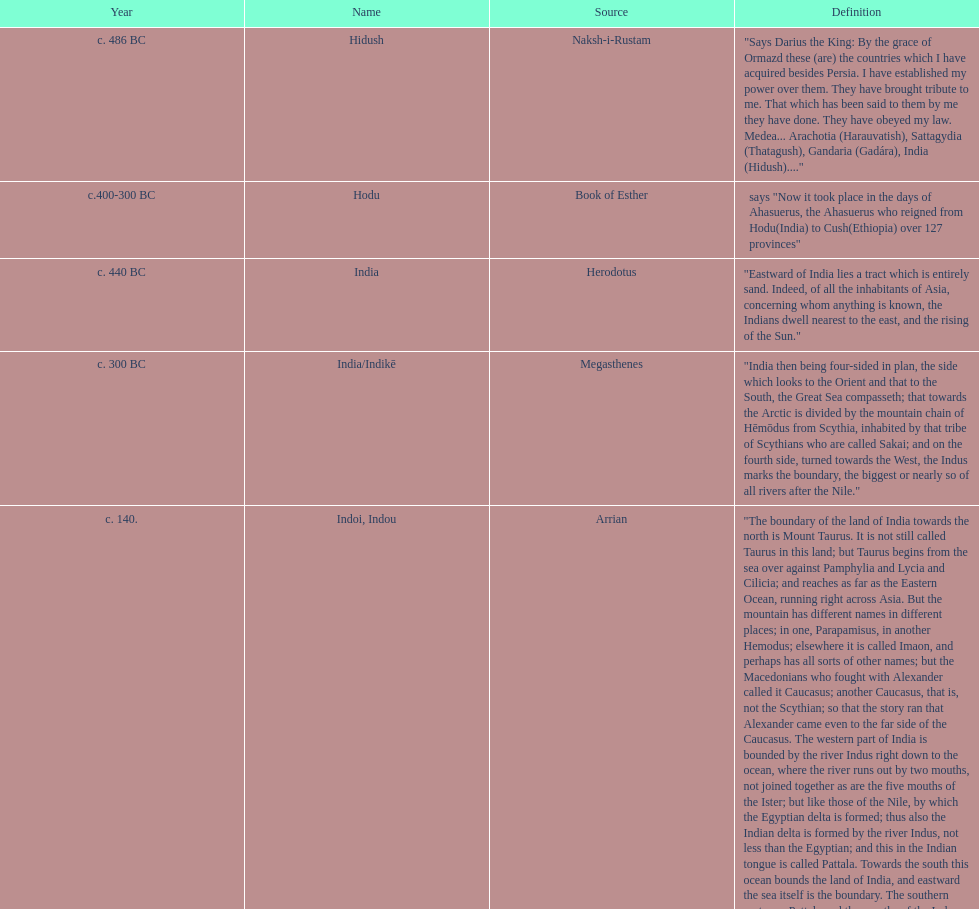Which is the most recent source for the name? Clavijo. Can you parse all the data within this table? {'header': ['Year', 'Name', 'Source', 'Definition'], 'rows': [['c. 486 BC', 'Hidush', 'Naksh-i-Rustam', '"Says Darius the King: By the grace of Ormazd these (are) the countries which I have acquired besides Persia. I have established my power over them. They have brought tribute to me. That which has been said to them by me they have done. They have obeyed my law. Medea... Arachotia (Harauvatish), Sattagydia (Thatagush), Gandaria (Gadára), India (Hidush)...."'], ['c.400-300 BC', 'Hodu', 'Book of Esther', 'says "Now it took place in the days of Ahasuerus, the Ahasuerus who reigned from Hodu(India) to Cush(Ethiopia) over 127 provinces"'], ['c. 440 BC', 'India', 'Herodotus', '"Eastward of India lies a tract which is entirely sand. Indeed, of all the inhabitants of Asia, concerning whom anything is known, the Indians dwell nearest to the east, and the rising of the Sun."'], ['c. 300 BC', 'India/Indikē', 'Megasthenes', '"India then being four-sided in plan, the side which looks to the Orient and that to the South, the Great Sea compasseth; that towards the Arctic is divided by the mountain chain of Hēmōdus from Scythia, inhabited by that tribe of Scythians who are called Sakai; and on the fourth side, turned towards the West, the Indus marks the boundary, the biggest or nearly so of all rivers after the Nile."'], ['c. 140.', 'Indoi, Indou', 'Arrian', '"The boundary of the land of India towards the north is Mount Taurus. It is not still called Taurus in this land; but Taurus begins from the sea over against Pamphylia and Lycia and Cilicia; and reaches as far as the Eastern Ocean, running right across Asia. But the mountain has different names in different places; in one, Parapamisus, in another Hemodus; elsewhere it is called Imaon, and perhaps has all sorts of other names; but the Macedonians who fought with Alexander called it Caucasus; another Caucasus, that is, not the Scythian; so that the story ran that Alexander came even to the far side of the Caucasus. The western part of India is bounded by the river Indus right down to the ocean, where the river runs out by two mouths, not joined together as are the five mouths of the Ister; but like those of the Nile, by which the Egyptian delta is formed; thus also the Indian delta is formed by the river Indus, not less than the Egyptian; and this in the Indian tongue is called Pattala. Towards the south this ocean bounds the land of India, and eastward the sea itself is the boundary. The southern part near Pattala and the mouths of the Indus were surveyed by Alexander and Macedonians, and many Greeks; as for the eastern part, Alexander did not traverse this beyond the river Hyphasis. A few historians have described the parts which are this side of the Ganges and where are the mouths of the Ganges and the city of Palimbothra, the greatest Indian city on the Ganges. (...) The Indian rivers are greater than any others in Asia; greatest are the Ganges and the Indus, whence the land gets its name; each of these is greater than the Nile of Egypt and the Scythian Ister, even were these put together; my own idea is that even the Acesines is greater than the Ister and the Nile, where the Acesines having taken in the Hydaspes, Hydraotes, and Hyphasis, runs into the Indus, so that its breadth there becomes thirty stades. Possibly also other greater rivers run through the land of India."'], ['320 CE or later', 'Bhāratam', 'Vishnu Purana', '"उत्तरं यत्समुद्रस्य हिमाद्रेश्चैव दक्षिणम् ।\\nवर्षं तद् भारतं नाम भारती यत्र संततिः ।।"\\ni.e. "The country (varṣam) that lies north of the ocean and south of the snowy mountains is called Bhāratam; there dwell the descendants of Bharata."'], ['c. 590.', 'Hind', 'Istakhri', '"As for the land of the Hind it is bounded on the East by the Persian Sea (i.e. the Indian Ocean), on the W. and S. by the countries of Islām, and on the N. by the Chinese Empire. . . . The length of the land of the Hind from the government of Mokrān, the country of Mansūra and Bodha and the rest of Sind, till thou comest to Kannūj and thence passest on to Tibet, is about 4 months, and its breadth from the Indian Ocean to the country of Kannūj about three months."'], ['c. 650', 'Five Indies', 'Xuanzang', '"The circumference of 五印 (Modern Chinese: Wǔ Yìn, the Five Indies) is about 90,000 li; on three sides it is bounded by a great sea; on the north it is backed by snowy mountains. It is wide at the north and narrow at the south; its figure is that of a half-moon."'], ['c. 944.', 'Hind, Sind', 'Masudi', '"For the nonce let us confine ourselves to summary notices concerning the kings of Sind and Hind. The language of Sind is different from that of Hind. . . ."'], ['c. 1020', 'Hind', 'Al-Birūnī', '"Hind is surrounded on the East by Chín and Máchín, on the West by Sind and Kábul, and on the South by the Sea."-'], ['1205', 'Hind', 'Hasan Nizāmī', '"The whole country of Hind, from Peshawar in the north, to the Indian Ocean in the south; from Sehwan (on the west bank of the Indus) to the mountains on the east dividing from China."'], ['1298', 'India the Greater\\nIndia the Minor\\nMiddle India', 'Marco Polo', '"India the Greater is that which extends from Maabar to Kesmacoran (i.e. from Coromandel to Mekran), and it contains 13 great kingdoms. . . . India the Lesser extends from the Province of Champa to Mutfili (i.e. from Cochin-China to the Kistna Delta), and contains 8 great Kingdoms. . . . Abash (Abyssinia) is a very great province, and you must know that it constitutes the Middle India."'], ['c. 1328.', 'India', 'Friar Jordanus', '"What shall I say? The great- ness of this India is beyond description. But let this much suffice concerning India the Greater and the Less. Of India Tertia I will say this, that I have not indeed seen its many marvels, not having been there. . . ."'], ['1404', 'India Minor', 'Clavijo', '"And this same Thursday that the said Ambassadors arrived at this great River (the Oxus) they crossed to the other side. And the same day . . . came in the evening to a great city which is called Tenmit (Termez), and this used to belong to India Minor, but now belongs to the empire of Samarkand, having been conquered by Tamurbec."']]} 